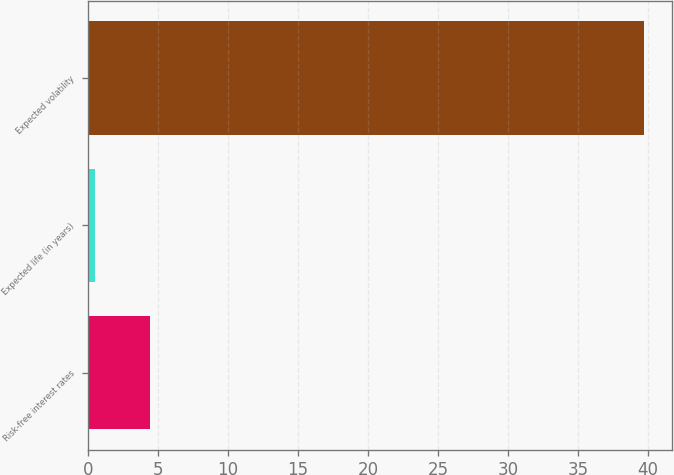Convert chart. <chart><loc_0><loc_0><loc_500><loc_500><bar_chart><fcel>Risk-free interest rates<fcel>Expected life (in years)<fcel>Expected volatility<nl><fcel>4.42<fcel>0.5<fcel>39.7<nl></chart> 